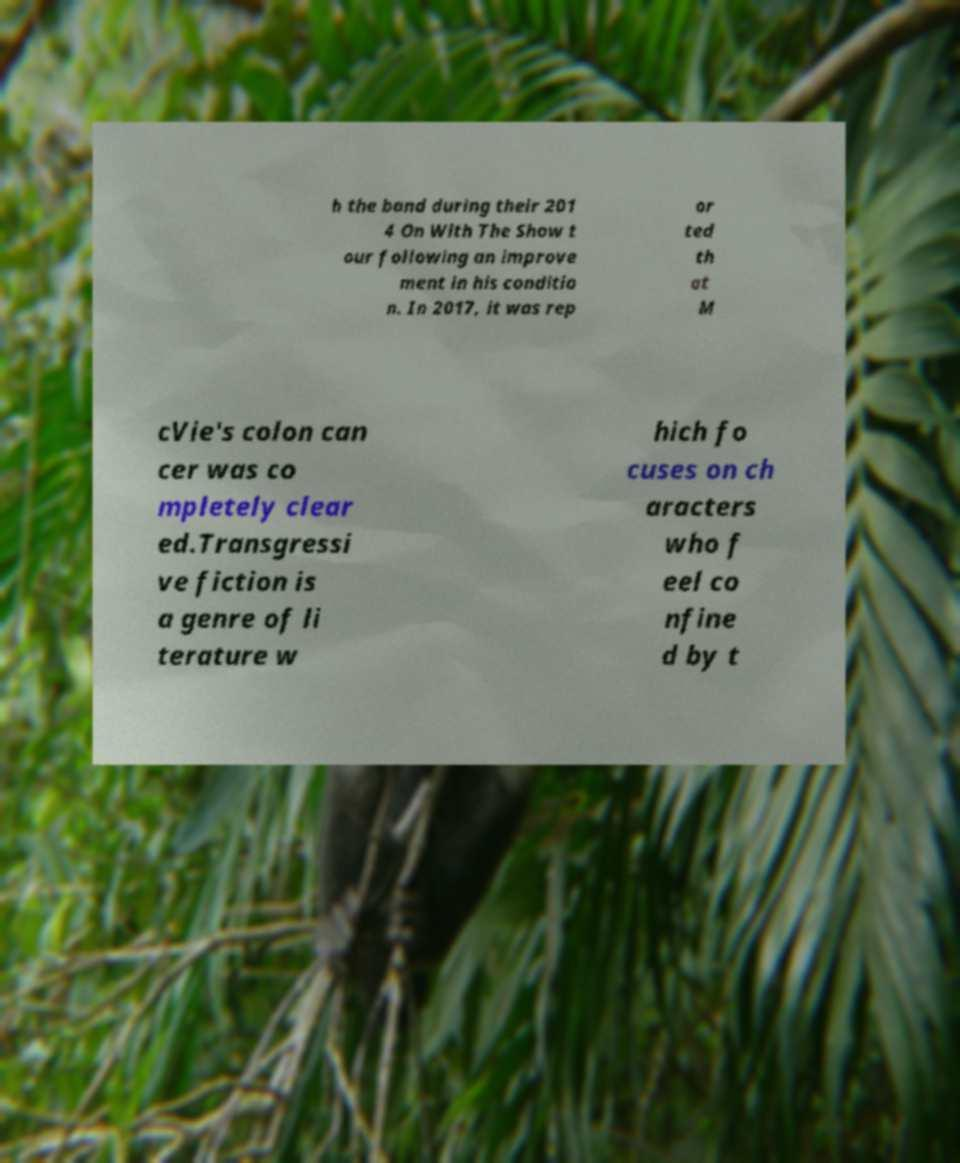I need the written content from this picture converted into text. Can you do that? h the band during their 201 4 On With The Show t our following an improve ment in his conditio n. In 2017, it was rep or ted th at M cVie's colon can cer was co mpletely clear ed.Transgressi ve fiction is a genre of li terature w hich fo cuses on ch aracters who f eel co nfine d by t 